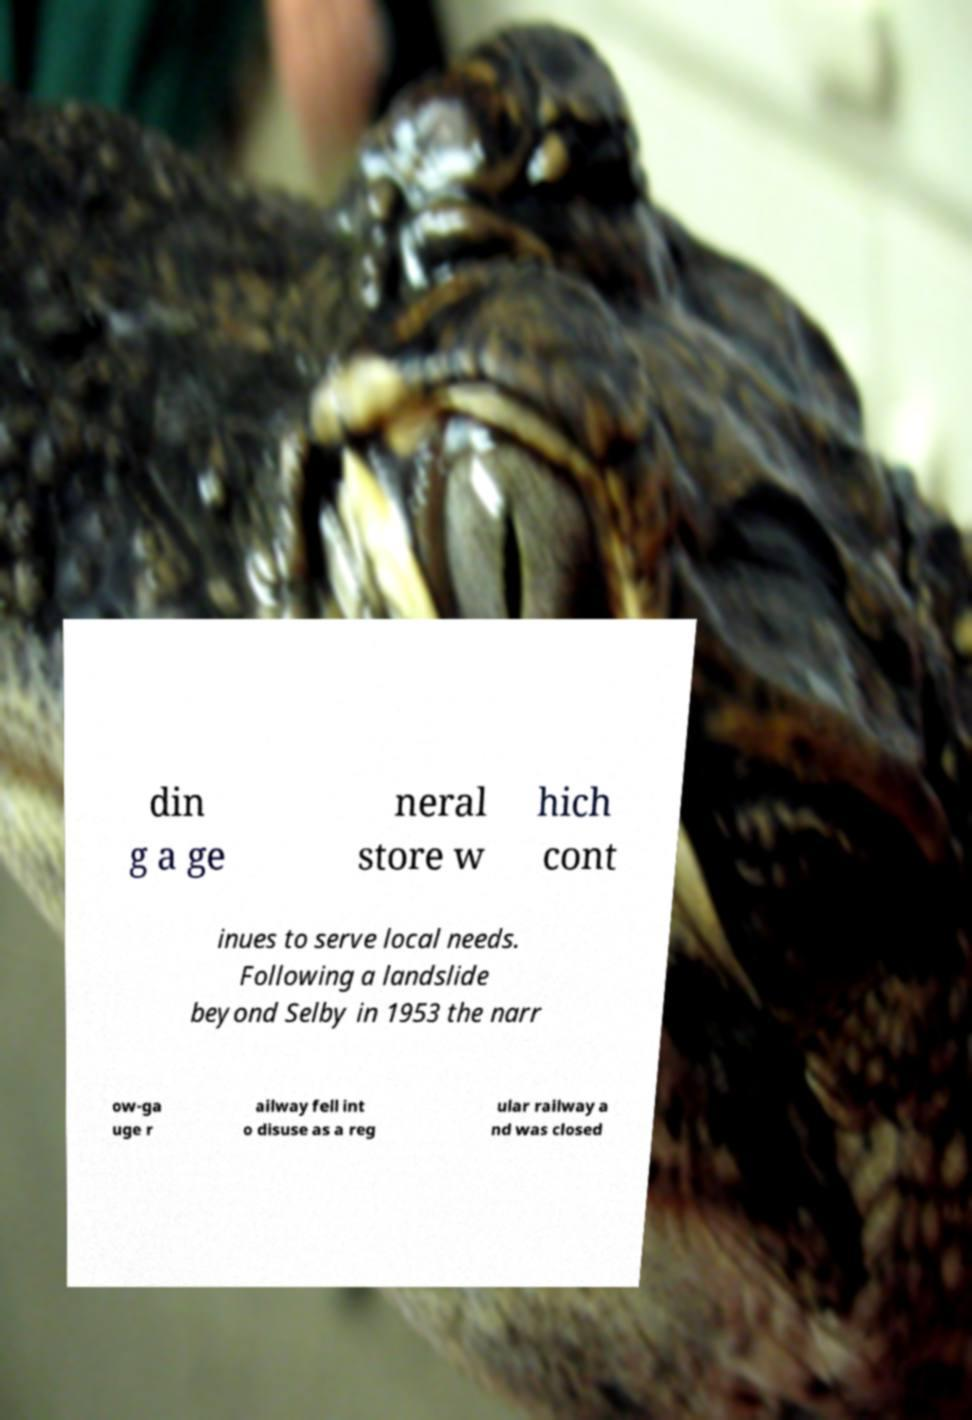What messages or text are displayed in this image? I need them in a readable, typed format. din g a ge neral store w hich cont inues to serve local needs. Following a landslide beyond Selby in 1953 the narr ow-ga uge r ailway fell int o disuse as a reg ular railway a nd was closed 